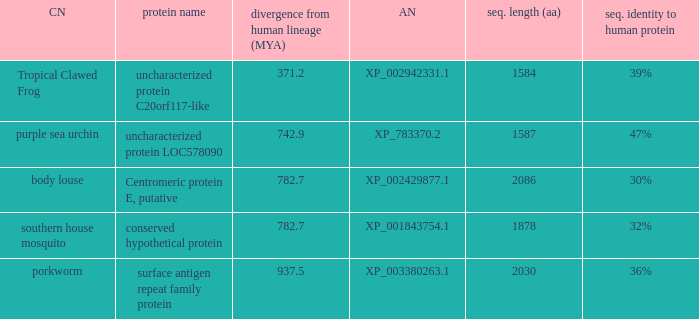What is the accession number of the protein with the common name Purple Sea Urchin? XP_783370.2. 